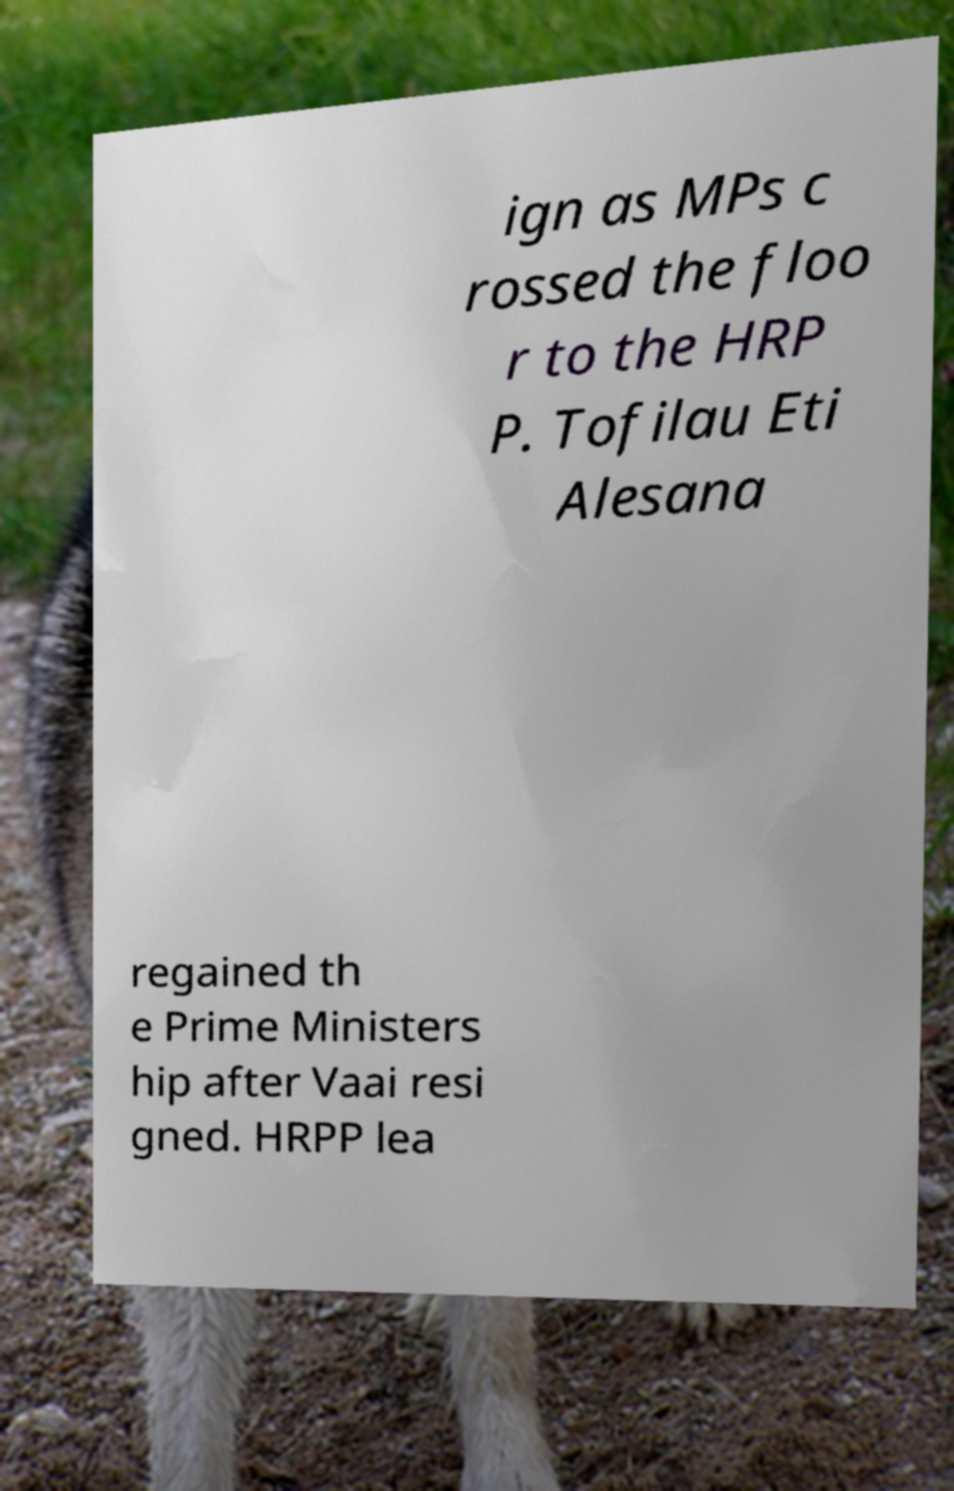Could you assist in decoding the text presented in this image and type it out clearly? ign as MPs c rossed the floo r to the HRP P. Tofilau Eti Alesana regained th e Prime Ministers hip after Vaai resi gned. HRPP lea 